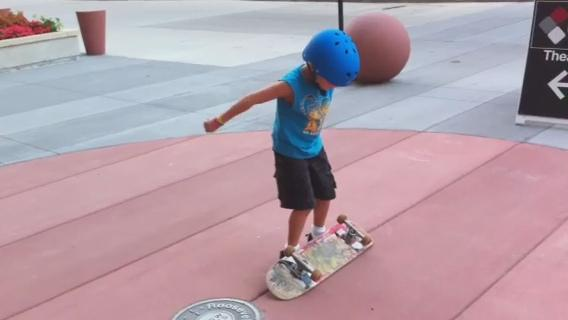What will the child try to do first?

Choices:
A) rest
B) flip board
C) yell
D) eat flip board 